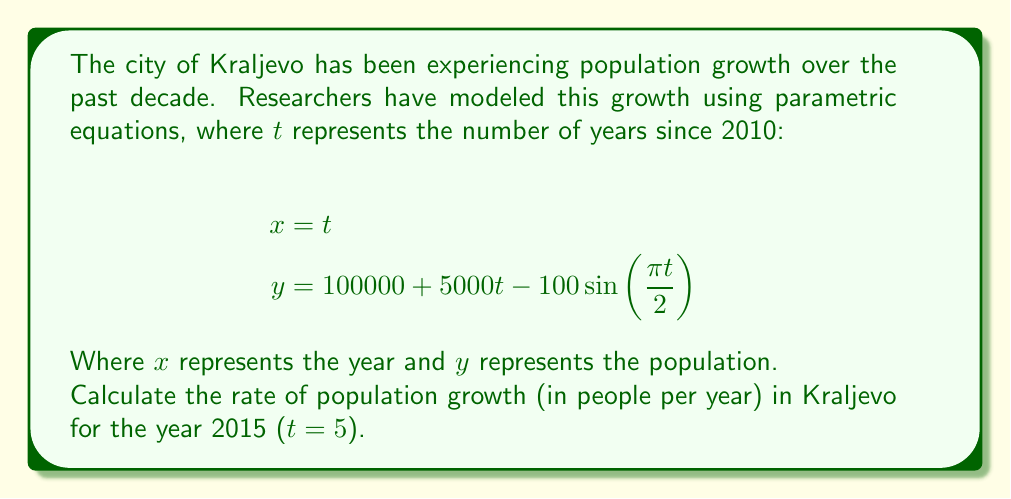What is the answer to this math problem? To solve this problem, we need to follow these steps:

1) The rate of population growth is represented by the derivative of y with respect to t.

2) First, let's find $\frac{dy}{dt}$ using the chain rule:

   $$\frac{dy}{dt} = 5000 - 100 \cdot \frac{\pi}{2} \cos(\frac{\pi t}{2})$$

3) Now, we need to evaluate this at t = 5 (representing the year 2015):

   $$\frac{dy}{dt}\Big|_{t=5} = 5000 - 100 \cdot \frac{\pi}{2} \cos(\frac{5\pi}{2})$$

4) Simplify:
   $$= 5000 - 50\pi \cos(\frac{5\pi}{2})$$

5) Note that $\cos(\frac{5\pi}{2}) = 0$

6) Therefore:
   $$\frac{dy}{dt}\Big|_{t=5} = 5000 - 50\pi \cdot 0 = 5000$$

This means the population is growing at a rate of 5000 people per year in 2015.
Answer: 5000 people/year 